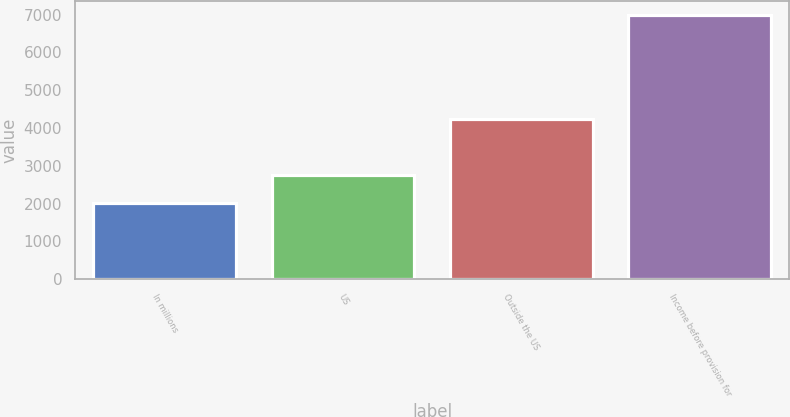Convert chart. <chart><loc_0><loc_0><loc_500><loc_500><bar_chart><fcel>In millions<fcel>US<fcel>Outside the US<fcel>Income before provision for<nl><fcel>2010<fcel>2763<fcel>4237.3<fcel>7000.3<nl></chart> 